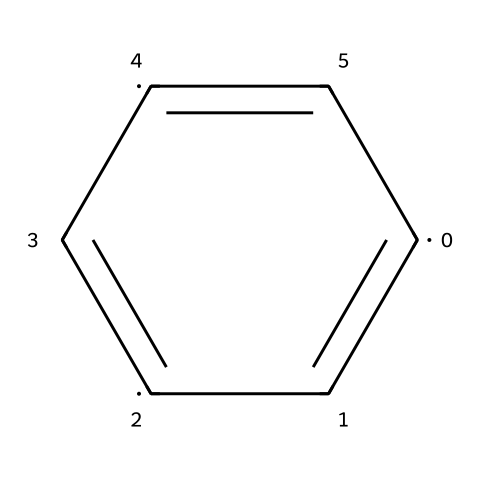What is the main elemental component of this structure? The structure contains carbon atoms, as indicated by the symbol "C" in the SMILES representation, which describes the chemical.
Answer: carbon How many carbon atoms are present in this chemical structure? The SMILES representation contains 6 carbon symbols, indicating there are 6 carbon atoms in the structure.
Answer: 6 What type of bonding is primarily represented in this structure? The structure consists of double bonds between carbon atoms, as indicated by the equal signs "=" in the SMILES; this signifies that the carbon atoms are interconnected via double bonds.
Answer: double bonding Is this chemical molecule cyclic or acyclic? The structure is circular, as the numbering of carbon atoms indicates a ring formation, which classifies it as a cyclic compound.
Answer: cyclic What is the general class of this chemical compound? This chemical belongs to the class of hydrocarbons known as polyenes, because it contains multiple double bonds between carbon atoms.
Answer: polyene How would you describe the degree of unsaturation in this structure? The presence of multiple double bonds indicates there is a high degree of unsaturation, which contributes to the molecule's reactivity compared to saturated hydrocarbons.
Answer: high What implications does this structure have for conductivity in batteries? The arrangement of carbon atoms and the presence of conjugated double bonds contribute to delocalized electrons, enhancing conductivity in applications such as batteries.
Answer: enhanced conductivity 